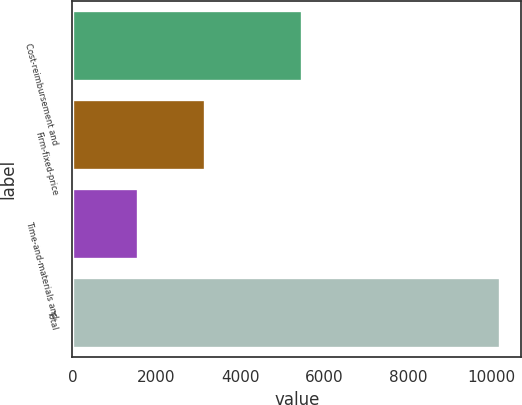<chart> <loc_0><loc_0><loc_500><loc_500><bar_chart><fcel>Cost-reimbursement and<fcel>Firm-fixed-price<fcel>Time-and-materials and<fcel>Total<nl><fcel>5469<fcel>3169<fcel>1556<fcel>10194<nl></chart> 